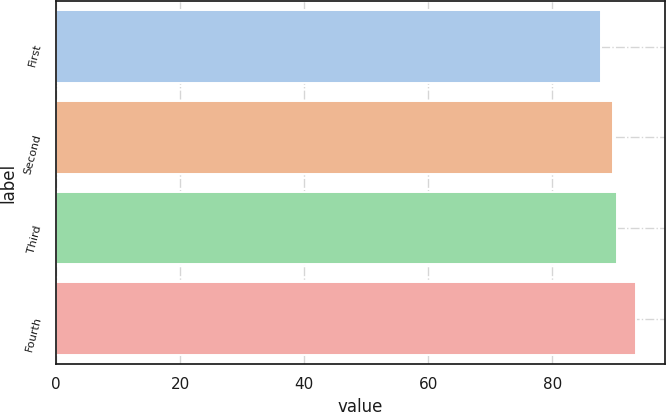<chart> <loc_0><loc_0><loc_500><loc_500><bar_chart><fcel>First<fcel>Second<fcel>Third<fcel>Fourth<nl><fcel>87.8<fcel>89.85<fcel>90.41<fcel>93.45<nl></chart> 